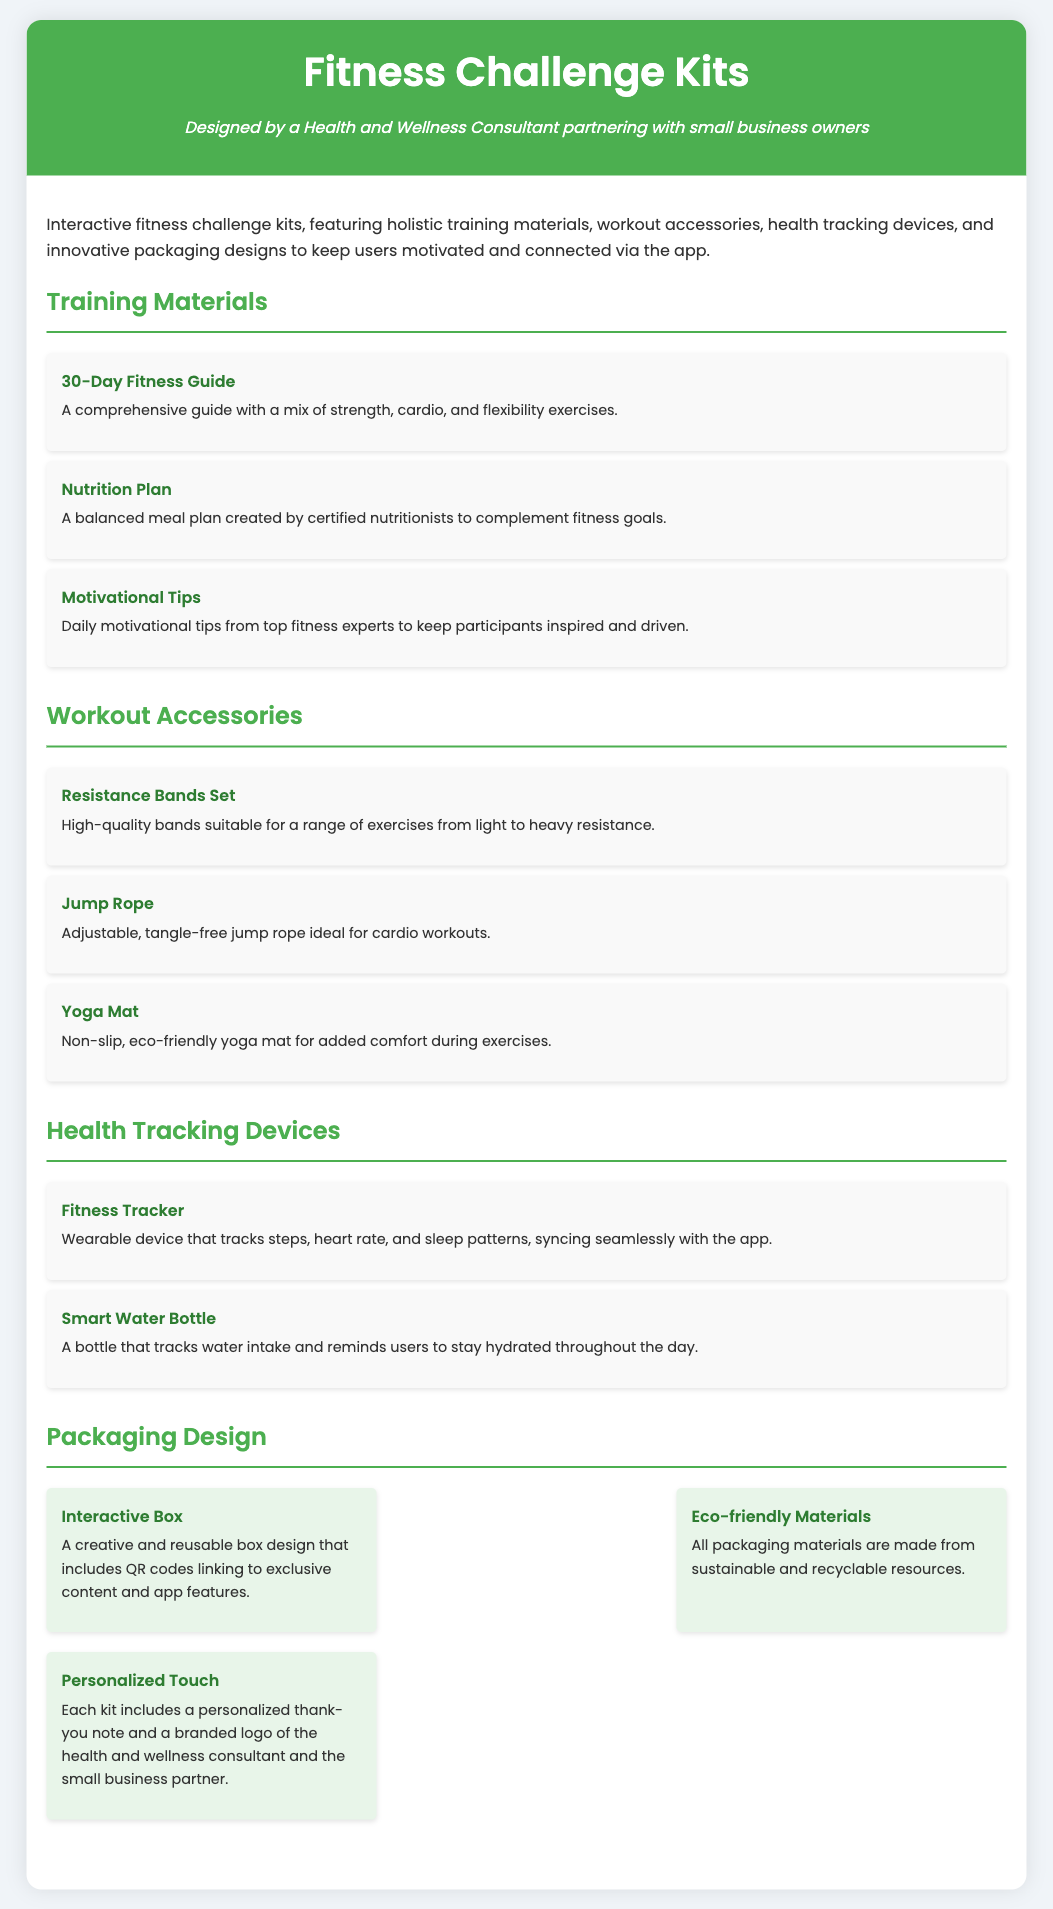What is included in the Fitness Challenge Kits? The kits include training materials, workout accessories, and health tracking devices.
Answer: training materials, workout accessories, health tracking devices How many resistance bands are in the set? The document does not specify a number for the resistance bands set.
Answer: Not specified What device tracks steps, heart rate, and sleep patterns? This information is found in the section on health tracking devices, which describes the fitness tracker.
Answer: Fitness Tracker What type of yoga mat is offered? The document describes the yoga mat as non-slip and eco-friendly.
Answer: Non-slip, eco-friendly What feature supports interactive content in the packaging? The packaging design mentions QR codes linking to exclusive content and app features.
Answer: QR codes What is the purpose of the Smart Water Bottle? The document explains that it tracks water intake and reminds users to stay hydrated.
Answer: Tracks water intake How many training materials are listed in the document? The training materials section lists three items, which must be counted for this answer.
Answer: 3 What does the packaging use to reflect sustainability? The document states that all packaging materials are made from sustainable and recyclable resources.
Answer: Eco-friendly Materials What personalized element is included in each kit? The packaging section mentions a personalized thank-you note is included in each kit.
Answer: Personalized thank-you note 